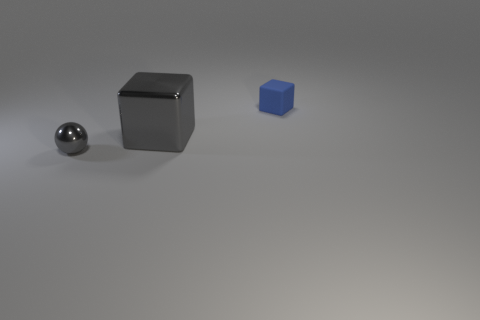Add 1 matte things. How many objects exist? 4 Subtract all blocks. How many objects are left? 1 Add 2 blue cubes. How many blue cubes exist? 3 Subtract 0 blue spheres. How many objects are left? 3 Subtract all blue rubber balls. Subtract all gray metallic cubes. How many objects are left? 2 Add 1 tiny blue matte objects. How many tiny blue matte objects are left? 2 